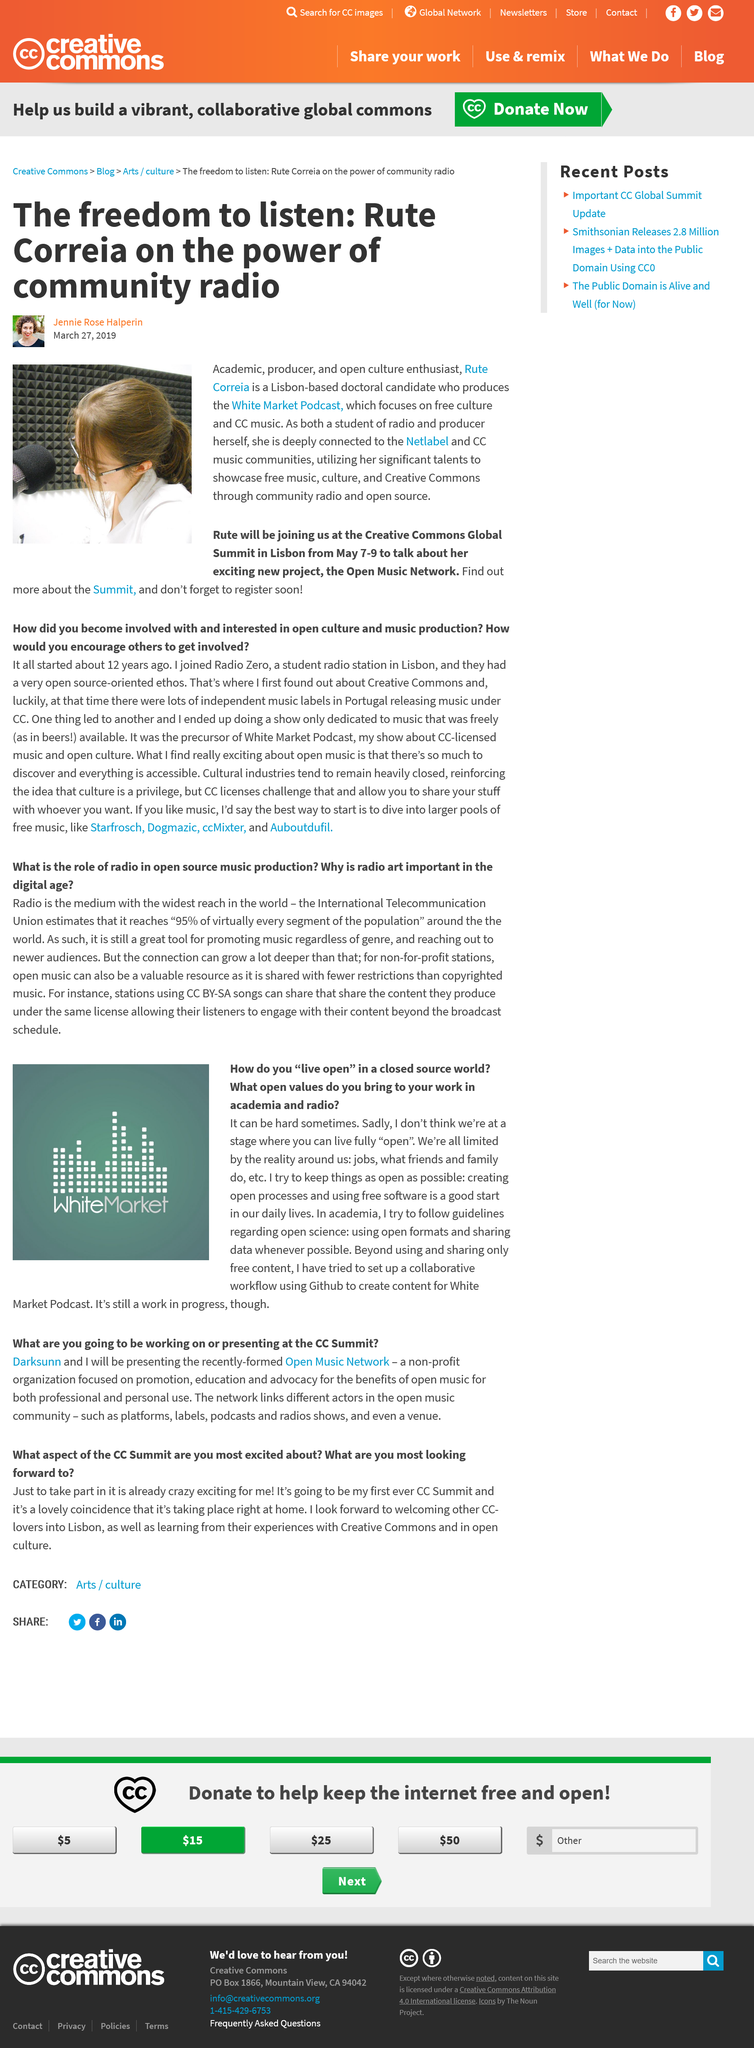Point out several critical features in this image. It is advisable to maintain openness by establishing open processes and utilizing free software. The academic and open culture enthusiast, Rute, will be joining the Creative Commons Global Summit from May 7-9. The Open Music Network is the new project of Rute Correia. The limitations that we face are not just imposed by the reality around us, but also by our jobs, friends, and family. Jennie Rose Halperin wrote the Freedom to Listen article. 